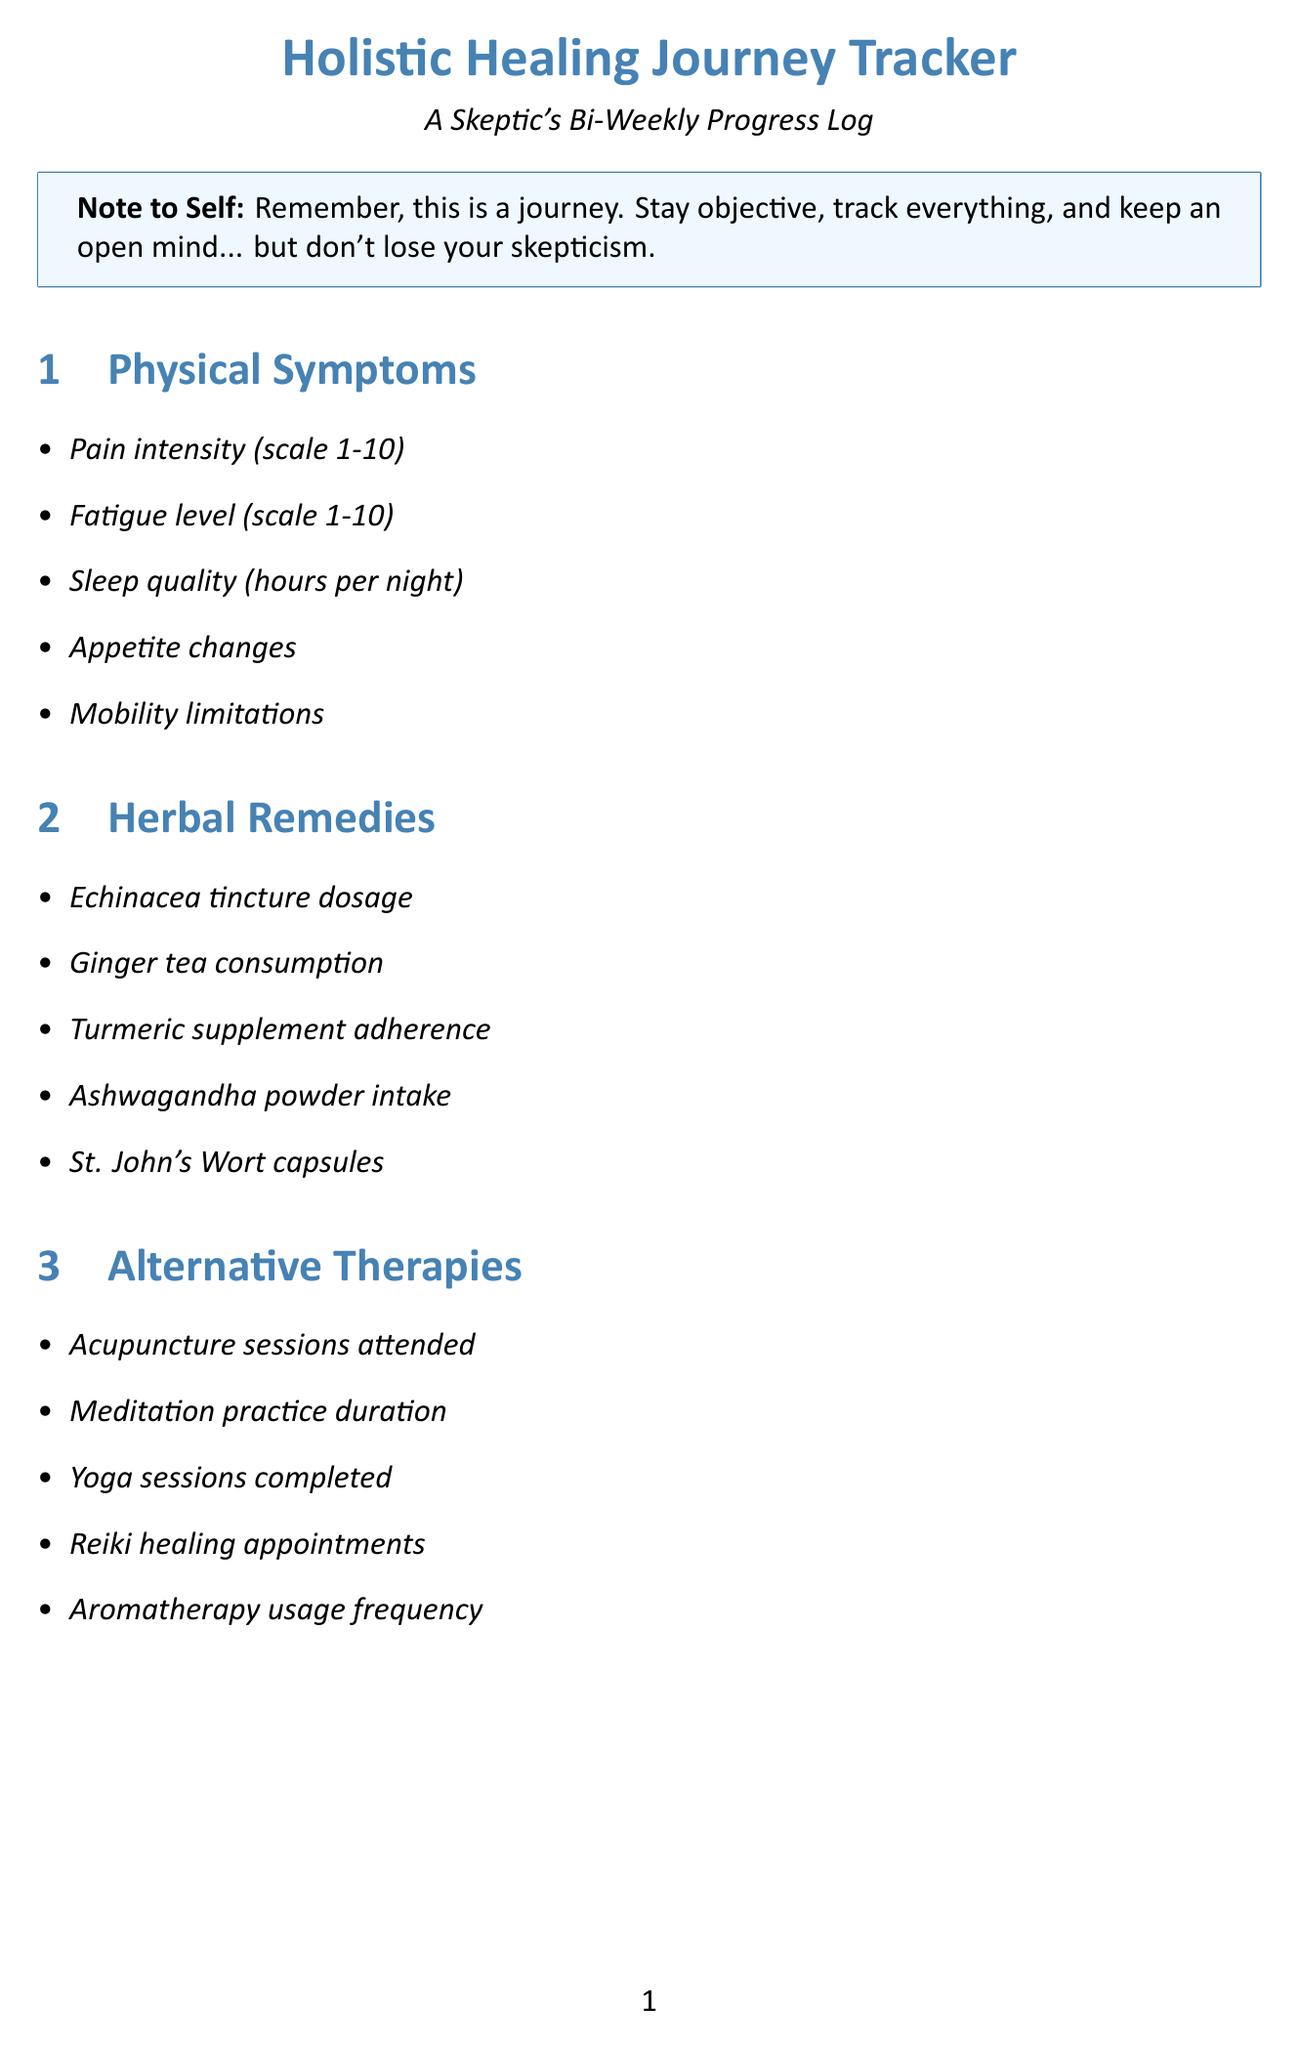What is the maximum pain intensity scale? The document mentions that pain intensity is measured on a scale of 1 to 10.
Answer: 10 How frequently should lifestyle changes be tracked? The document indicates that the progress log is updated bi-weekly.
Answer: Bi-weekly What is one example of an emotional well-being item? The document lists "Mood fluctuations" as one of the items under the emotional well-being category.
Answer: Mood fluctuations How many categories are there in the progress tracker? The document outlines a total of eight categories in the progress tracker.
Answer: Eight What is the focus of the "Long-term Goals" section? The Long-term Goals section aims at symptom reduction targets and personal health knowledge expansion.
Answer: Symptom reduction targets What remedy is noted for its dosage tracking? The document includes "Echinacea tincture dosage" as an item in the herbal remedies category.
Answer: Echinacea tincture dosage Which category includes "Acupuncture sessions attended"? This item falls under the "Alternative Therapies" category in the progress tracker.
Answer: Alternative Therapies What is the purpose of this document? The document is designed as a bi-weekly progress log for a skeptic tracking their holistic healing journey.
Answer: Holistic Healing Journey Tracker 